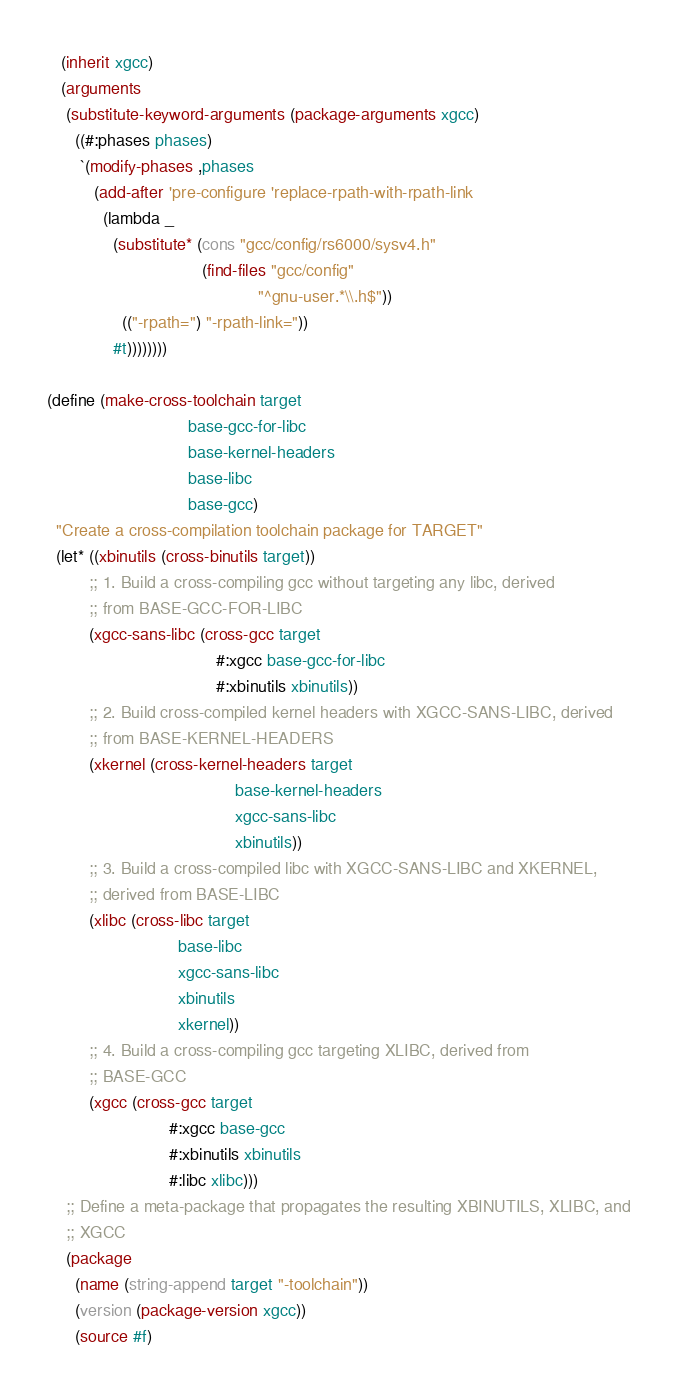<code> <loc_0><loc_0><loc_500><loc_500><_Scheme_>   (inherit xgcc)
   (arguments
    (substitute-keyword-arguments (package-arguments xgcc)
      ((#:phases phases)
       `(modify-phases ,phases
          (add-after 'pre-configure 'replace-rpath-with-rpath-link
            (lambda _
              (substitute* (cons "gcc/config/rs6000/sysv4.h"
                                 (find-files "gcc/config"
                                             "^gnu-user.*\\.h$"))
                (("-rpath=") "-rpath-link="))
              #t))))))))

(define (make-cross-toolchain target
                              base-gcc-for-libc
                              base-kernel-headers
                              base-libc
                              base-gcc)
  "Create a cross-compilation toolchain package for TARGET"
  (let* ((xbinutils (cross-binutils target))
         ;; 1. Build a cross-compiling gcc without targeting any libc, derived
         ;; from BASE-GCC-FOR-LIBC
         (xgcc-sans-libc (cross-gcc target
                                    #:xgcc base-gcc-for-libc
                                    #:xbinutils xbinutils))
         ;; 2. Build cross-compiled kernel headers with XGCC-SANS-LIBC, derived
         ;; from BASE-KERNEL-HEADERS
         (xkernel (cross-kernel-headers target
                                        base-kernel-headers
                                        xgcc-sans-libc
                                        xbinutils))
         ;; 3. Build a cross-compiled libc with XGCC-SANS-LIBC and XKERNEL,
         ;; derived from BASE-LIBC
         (xlibc (cross-libc target
                            base-libc
                            xgcc-sans-libc
                            xbinutils
                            xkernel))
         ;; 4. Build a cross-compiling gcc targeting XLIBC, derived from
         ;; BASE-GCC
         (xgcc (cross-gcc target
                          #:xgcc base-gcc
                          #:xbinutils xbinutils
                          #:libc xlibc)))
    ;; Define a meta-package that propagates the resulting XBINUTILS, XLIBC, and
    ;; XGCC
    (package
      (name (string-append target "-toolchain"))
      (version (package-version xgcc))
      (source #f)</code> 